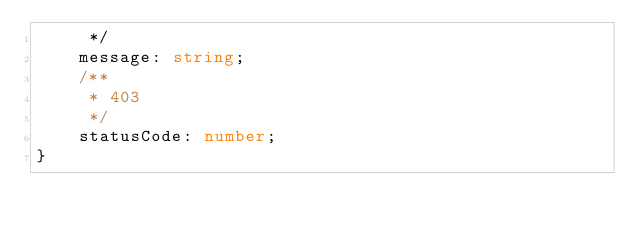Convert code to text. <code><loc_0><loc_0><loc_500><loc_500><_TypeScript_>     */
    message: string;
    /**
     * 403
     */
    statusCode: number;
}
</code> 